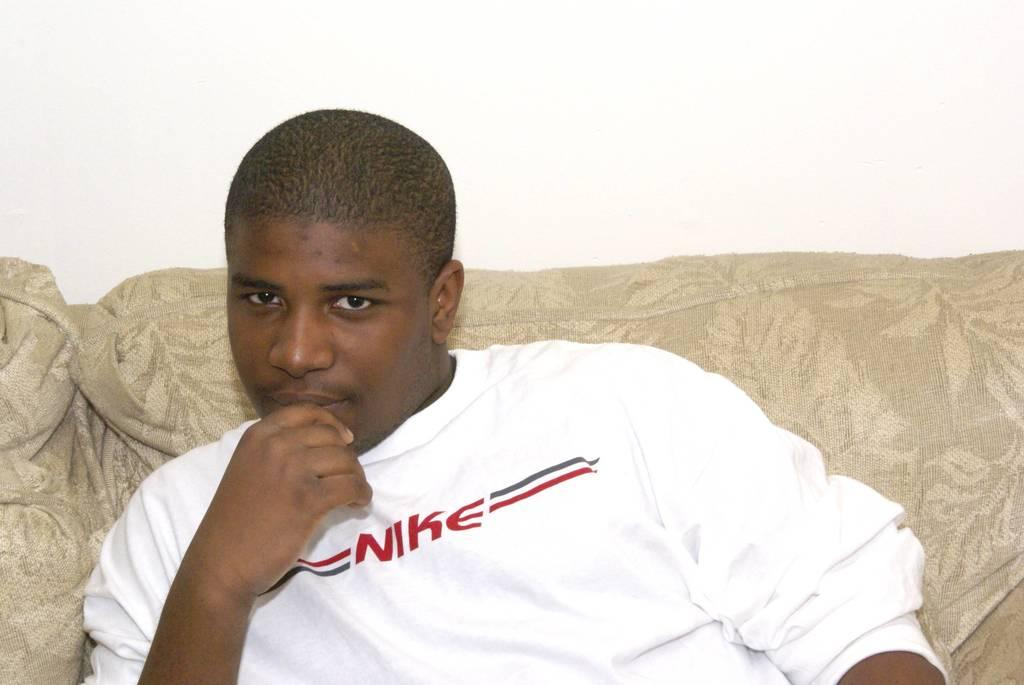<image>
Relay a brief, clear account of the picture shown. A man on a couch is wearing a white shirt that says Nike. 